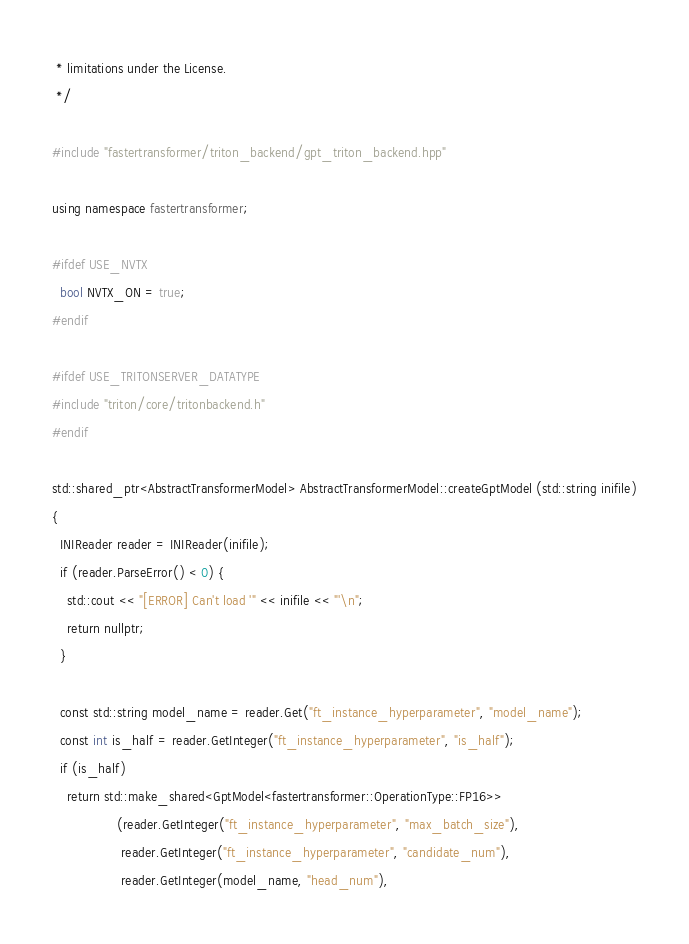<code> <loc_0><loc_0><loc_500><loc_500><_C++_> * limitations under the License.
 */

#include "fastertransformer/triton_backend/gpt_triton_backend.hpp"

using namespace fastertransformer;

#ifdef USE_NVTX
  bool NVTX_ON = true;
#endif

#ifdef USE_TRITONSERVER_DATATYPE
#include "triton/core/tritonbackend.h"
#endif

std::shared_ptr<AbstractTransformerModel> AbstractTransformerModel::createGptModel (std::string inifile)
{
  INIReader reader = INIReader(inifile);
  if (reader.ParseError() < 0) {
    std::cout << "[ERROR] Can't load '" << inifile << "'\n";
    return nullptr;
  }

  const std::string model_name = reader.Get("ft_instance_hyperparameter", "model_name");
  const int is_half = reader.GetInteger("ft_instance_hyperparameter", "is_half");
  if (is_half)
    return std::make_shared<GptModel<fastertransformer::OperationType::FP16>>
                 (reader.GetInteger("ft_instance_hyperparameter", "max_batch_size"),
                  reader.GetInteger("ft_instance_hyperparameter", "candidate_num"),
                  reader.GetInteger(model_name, "head_num"),</code> 